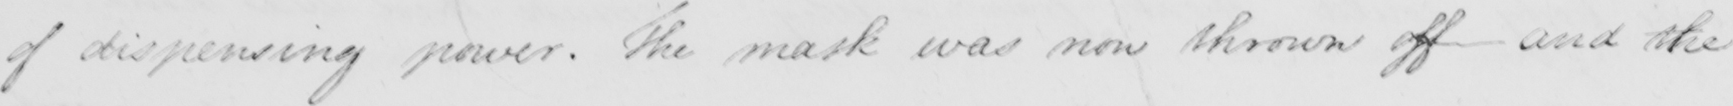What does this handwritten line say? of dispensing power . The mask was now thrown off and the 